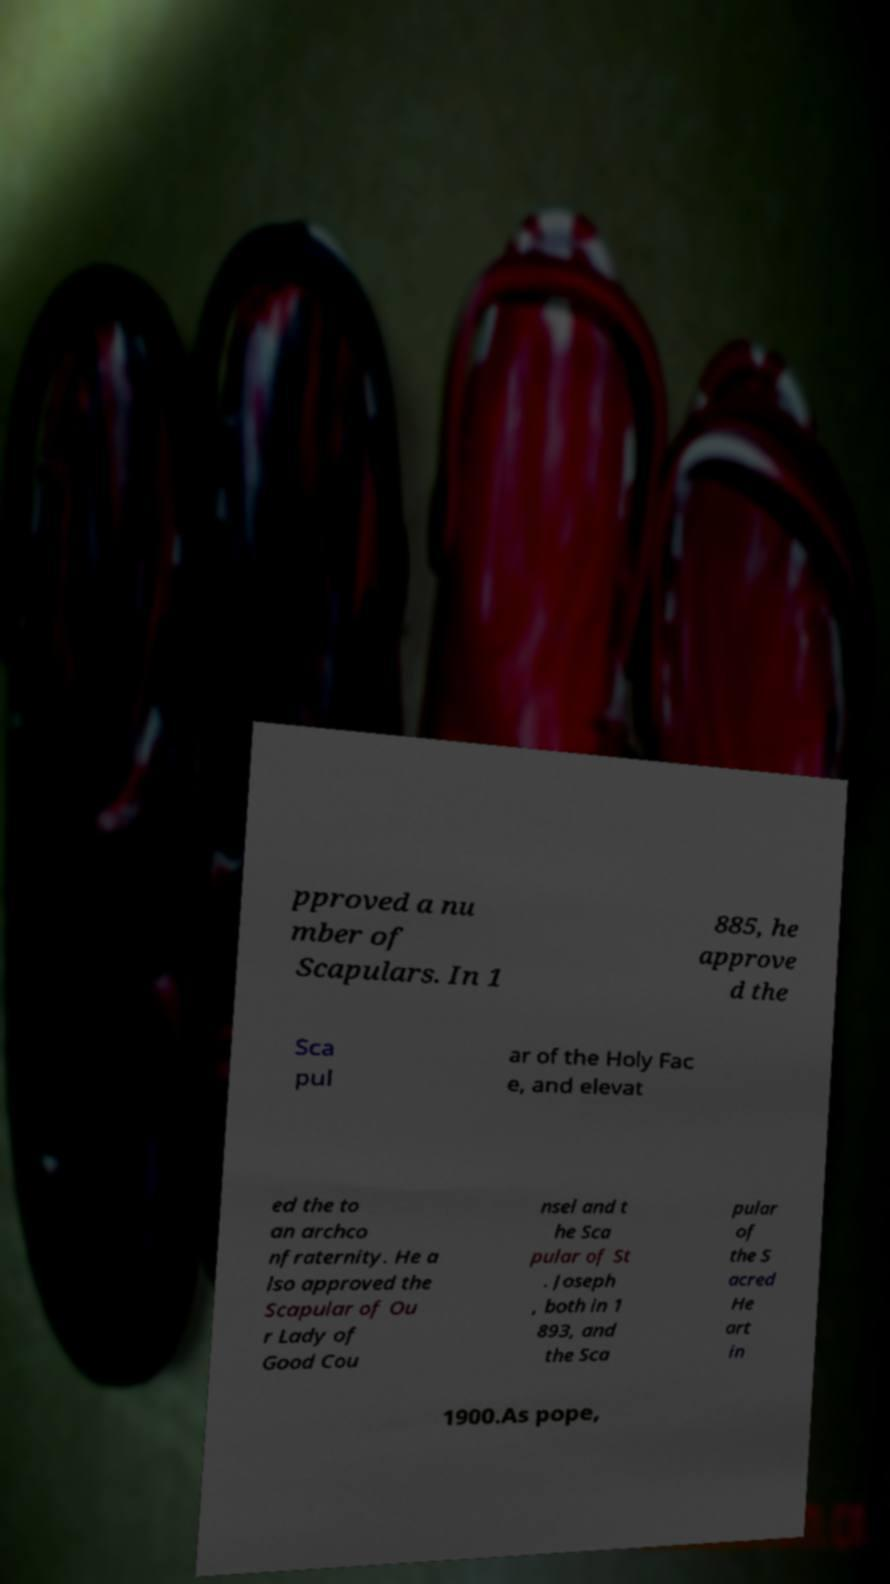What messages or text are displayed in this image? I need them in a readable, typed format. pproved a nu mber of Scapulars. In 1 885, he approve d the Sca pul ar of the Holy Fac e, and elevat ed the to an archco nfraternity. He a lso approved the Scapular of Ou r Lady of Good Cou nsel and t he Sca pular of St . Joseph , both in 1 893, and the Sca pular of the S acred He art in 1900.As pope, 